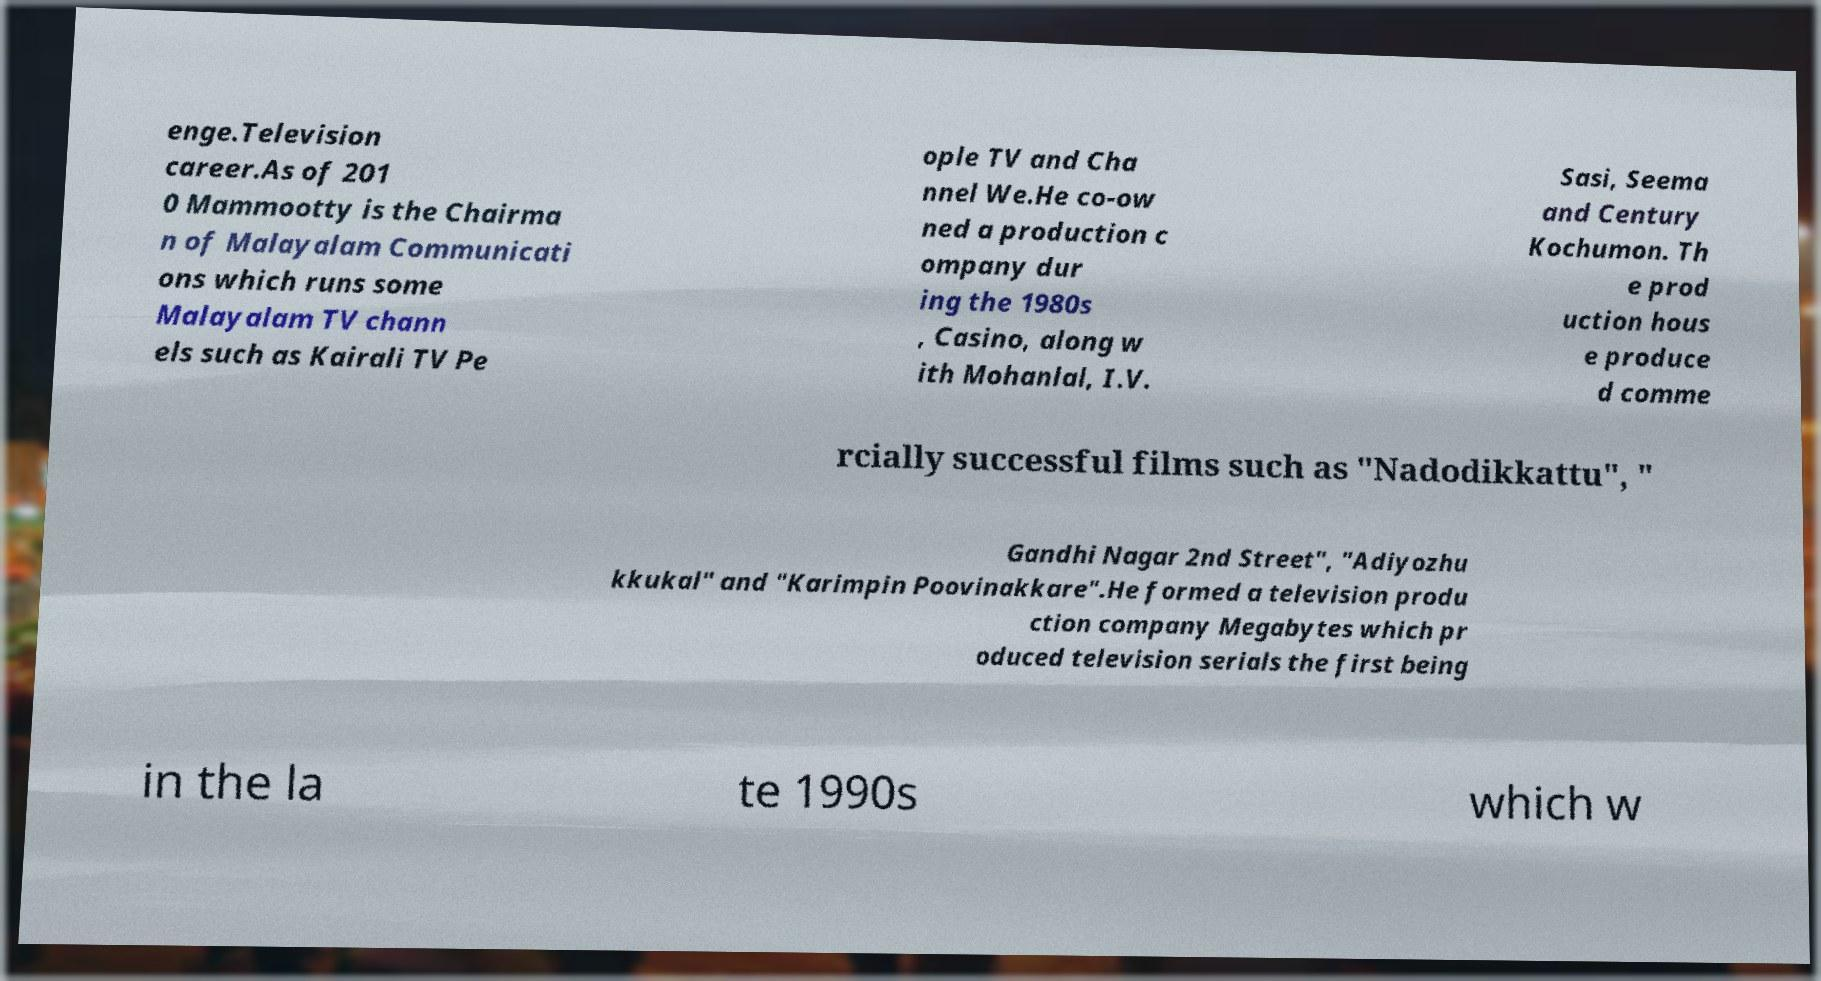There's text embedded in this image that I need extracted. Can you transcribe it verbatim? enge.Television career.As of 201 0 Mammootty is the Chairma n of Malayalam Communicati ons which runs some Malayalam TV chann els such as Kairali TV Pe ople TV and Cha nnel We.He co-ow ned a production c ompany dur ing the 1980s , Casino, along w ith Mohanlal, I.V. Sasi, Seema and Century Kochumon. Th e prod uction hous e produce d comme rcially successful films such as "Nadodikkattu", " Gandhi Nagar 2nd Street", "Adiyozhu kkukal" and "Karimpin Poovinakkare".He formed a television produ ction company Megabytes which pr oduced television serials the first being in the la te 1990s which w 